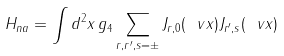Convert formula to latex. <formula><loc_0><loc_0><loc_500><loc_500>H _ { n a } = \int d ^ { 2 } x \, g _ { 4 } \sum _ { r , r ^ { \prime } , s = \pm } J _ { r , 0 } ( \ v x ) J _ { r ^ { \prime } , s } ( \ v x )</formula> 